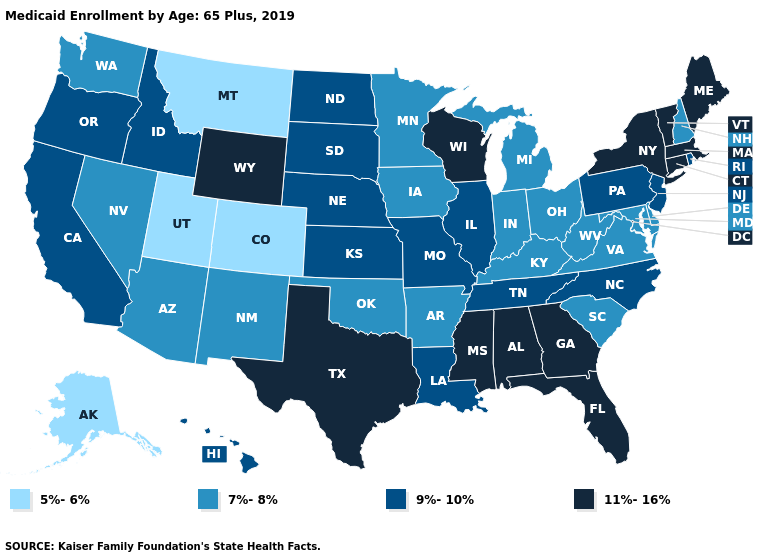What is the highest value in the MidWest ?
Short answer required. 11%-16%. Does the first symbol in the legend represent the smallest category?
Answer briefly. Yes. Does Wisconsin have the lowest value in the USA?
Keep it brief. No. Name the states that have a value in the range 5%-6%?
Be succinct. Alaska, Colorado, Montana, Utah. What is the highest value in the USA?
Concise answer only. 11%-16%. Which states have the highest value in the USA?
Concise answer only. Alabama, Connecticut, Florida, Georgia, Maine, Massachusetts, Mississippi, New York, Texas, Vermont, Wisconsin, Wyoming. Which states have the highest value in the USA?
Concise answer only. Alabama, Connecticut, Florida, Georgia, Maine, Massachusetts, Mississippi, New York, Texas, Vermont, Wisconsin, Wyoming. Which states have the lowest value in the USA?
Be succinct. Alaska, Colorado, Montana, Utah. Among the states that border Colorado , does Wyoming have the highest value?
Be succinct. Yes. What is the value of West Virginia?
Answer briefly. 7%-8%. What is the value of Connecticut?
Keep it brief. 11%-16%. Name the states that have a value in the range 5%-6%?
Concise answer only. Alaska, Colorado, Montana, Utah. Does Missouri have a lower value than Alaska?
Give a very brief answer. No. Name the states that have a value in the range 11%-16%?
Answer briefly. Alabama, Connecticut, Florida, Georgia, Maine, Massachusetts, Mississippi, New York, Texas, Vermont, Wisconsin, Wyoming. 